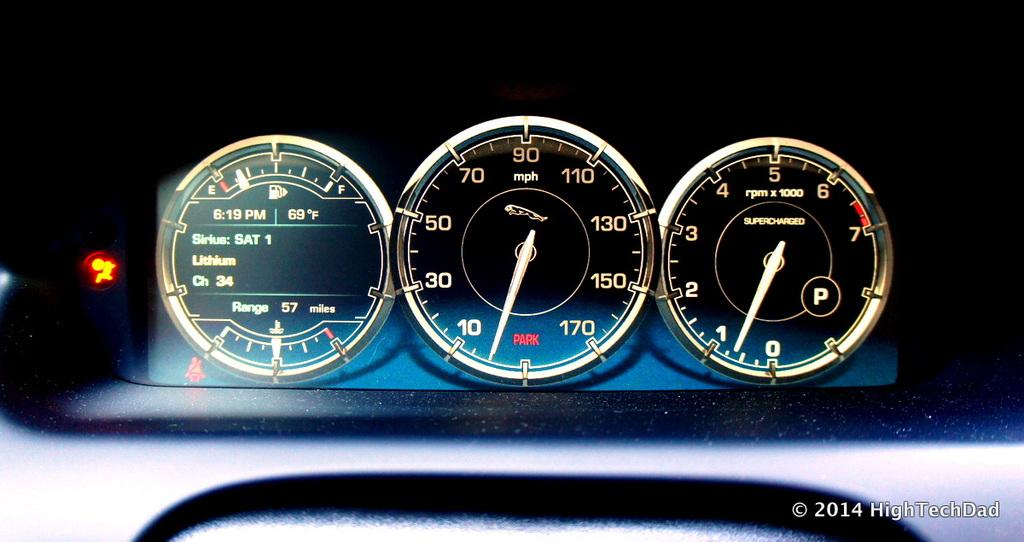What is the main subject of the image? The main subject of the image is a car's speedometer. How many meters are present in the speedometer? There are three meters in the speedometer. What type of apparatus is used to hammer nails in the image? There is no apparatus or hammer present in the image; it is a car's speedometer. Can you see a sink in the image? There is no sink present in the image; it is a car's speedometer. 